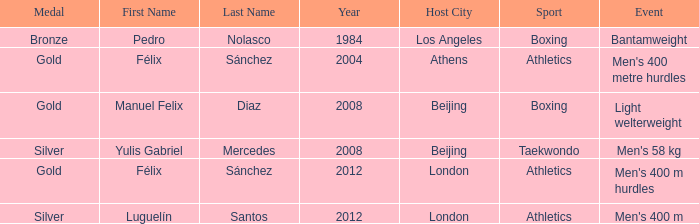What Medal had a Name of manuel felix diaz? Gold. 